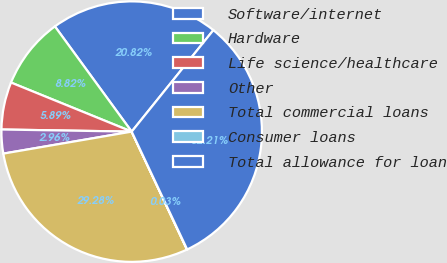Convert chart to OTSL. <chart><loc_0><loc_0><loc_500><loc_500><pie_chart><fcel>Software/internet<fcel>Hardware<fcel>Life science/healthcare<fcel>Other<fcel>Total commercial loans<fcel>Consumer loans<fcel>Total allowance for loan<nl><fcel>20.82%<fcel>8.82%<fcel>5.89%<fcel>2.96%<fcel>29.28%<fcel>0.03%<fcel>32.21%<nl></chart> 